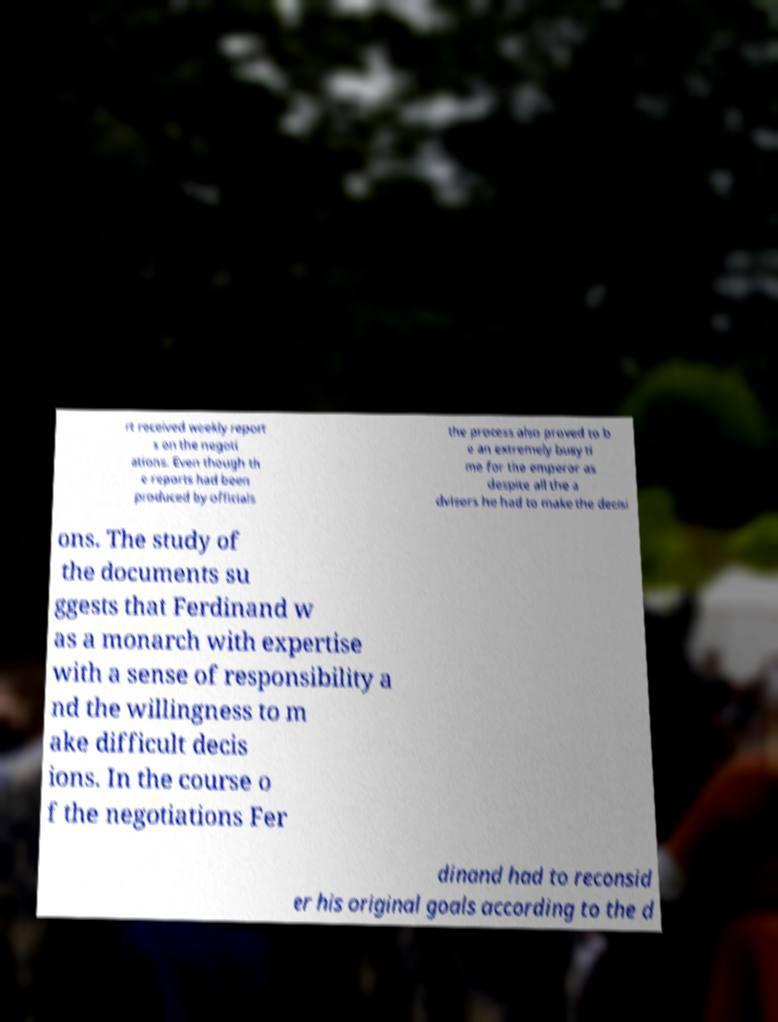I need the written content from this picture converted into text. Can you do that? rt received weekly report s on the negoti ations. Even though th e reports had been produced by officials the process also proved to b e an extremely busy ti me for the emperor as despite all the a dvisers he had to make the decisi ons. The study of the documents su ggests that Ferdinand w as a monarch with expertise with a sense of responsibility a nd the willingness to m ake difficult decis ions. In the course o f the negotiations Fer dinand had to reconsid er his original goals according to the d 